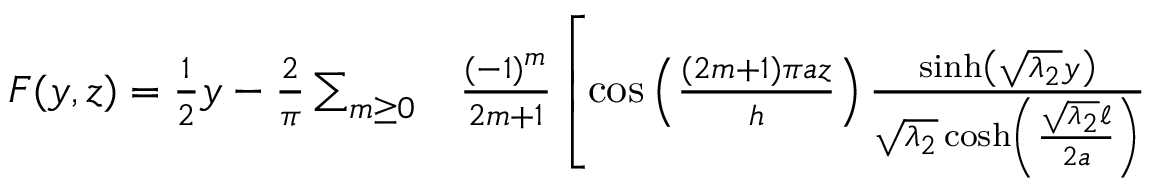<formula> <loc_0><loc_0><loc_500><loc_500>\begin{array} { r l } { F ( y , z ) = \frac { 1 } { 2 } y - \frac { 2 } { \pi } \sum _ { m \geq 0 } } & \frac { ( - 1 ) ^ { m } } { 2 m + 1 } \left [ \cos \left ( \frac { ( 2 m + 1 ) \pi a z } { h } \right ) \frac { \sinh \left ( \sqrt { \lambda _ { 2 } } y \right ) } { \sqrt { \lambda _ { 2 } } \cosh \left ( \frac { \sqrt { \lambda _ { 2 } } \ell } { 2 a } \right ) } } \end{array}</formula> 